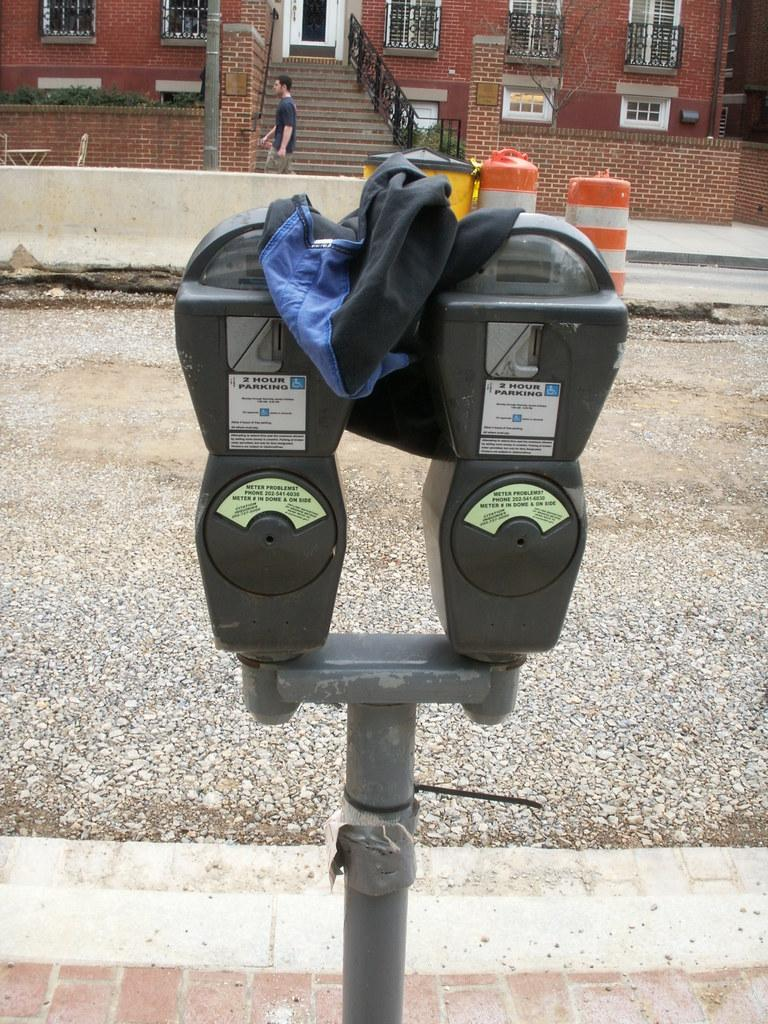<image>
Relay a brief, clear account of the picture shown. The longest one can park on this street is two hours. 